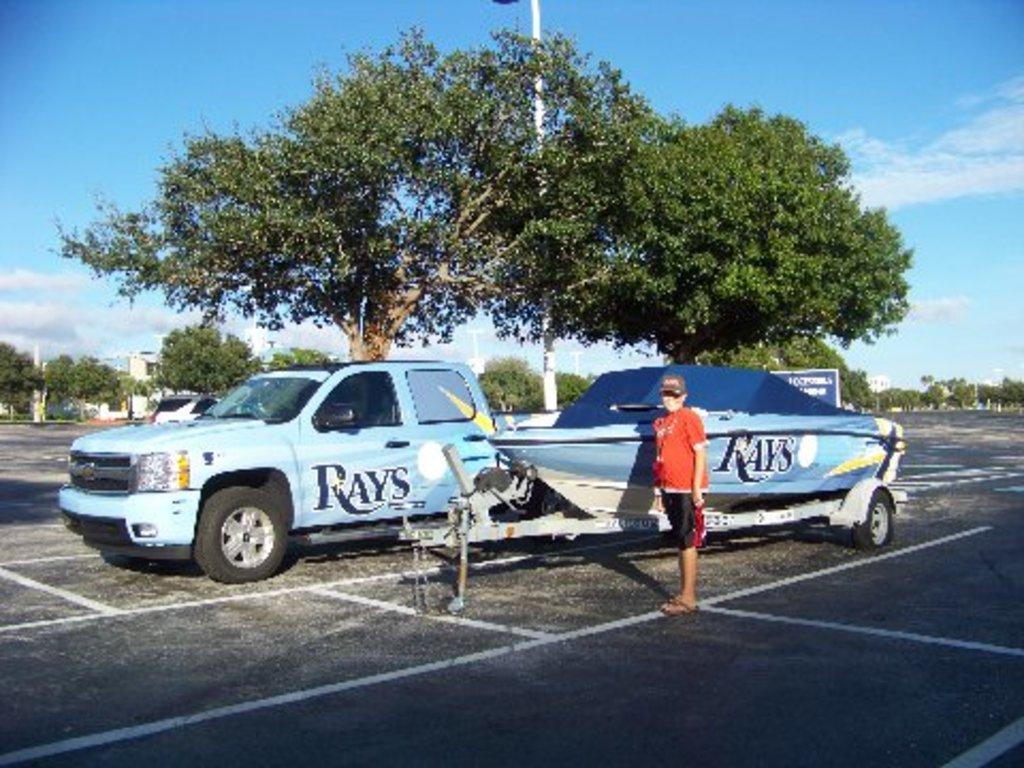Describe this image in one or two sentences. In the middle of the image a person is standing and watching. Behind him we can see some vehicles on the road. Behind the vehicles some poles and trees and buildings. At the top of the image we can see some clouds in the sky. 